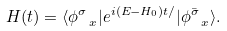<formula> <loc_0><loc_0><loc_500><loc_500>H ( t ) = \langle \phi ^ { \sigma } _ { \ x } | e ^ { i ( E - H _ { 0 } ) t / } | \phi ^ { \bar { \sigma } } _ { \ x } \rangle .</formula> 